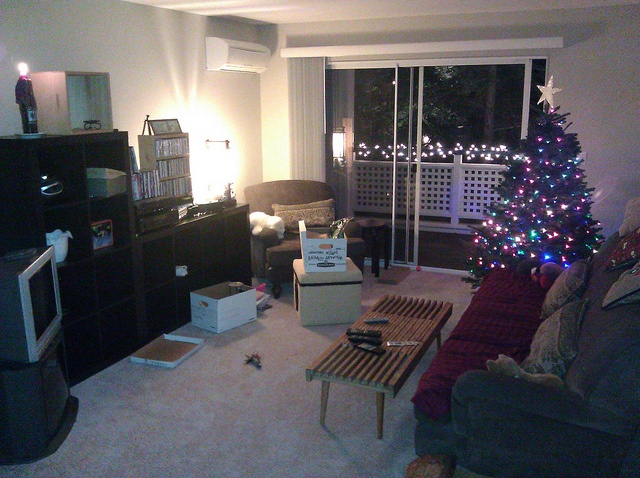Describe the objects in this image and their specific colors. I can see couch in gray, black, navy, and maroon tones, chair in gray, black, and tan tones, tv in gray, black, and teal tones, teddy bear in gray, black, and purple tones, and teddy bear in gray, ivory, and tan tones in this image. 